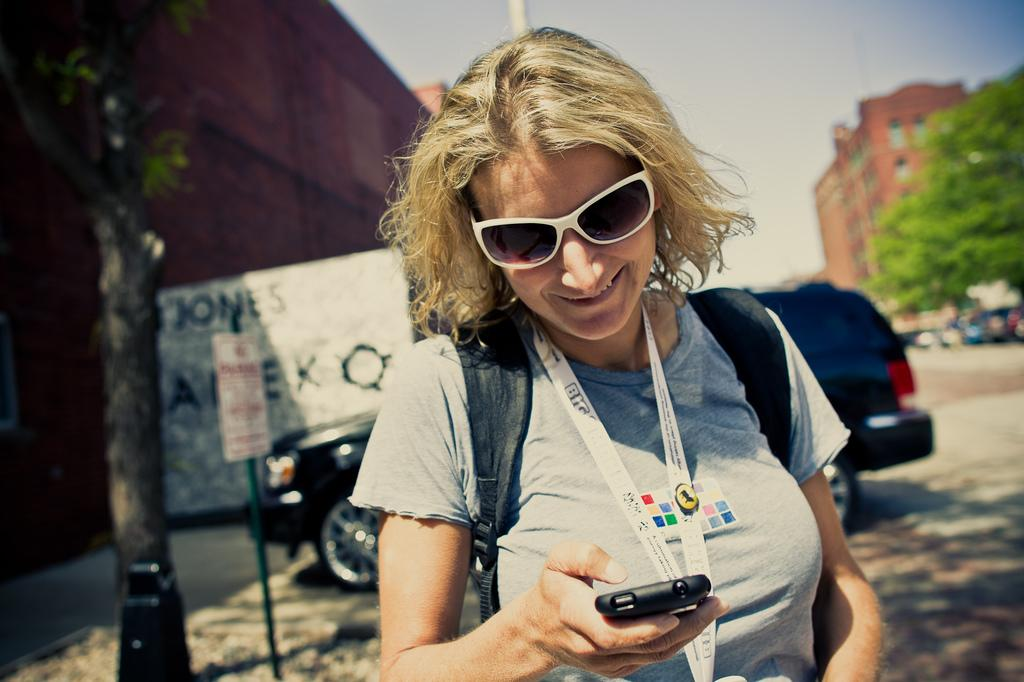Who is present in the image? There is a woman in the image. What is the woman holding in her hand? The woman is holding a cell phone in her hand. What can be seen in the background of the image? There is a vehicle, signs, a tree, a building, and the sky visible in the background of the image. What type of rice is being cooked by the band in the image? There is no band or rice present in the image. What type of cabbage is growing on the tree in the image? There is no cabbage growing on the tree in the image; it is a regular tree. 